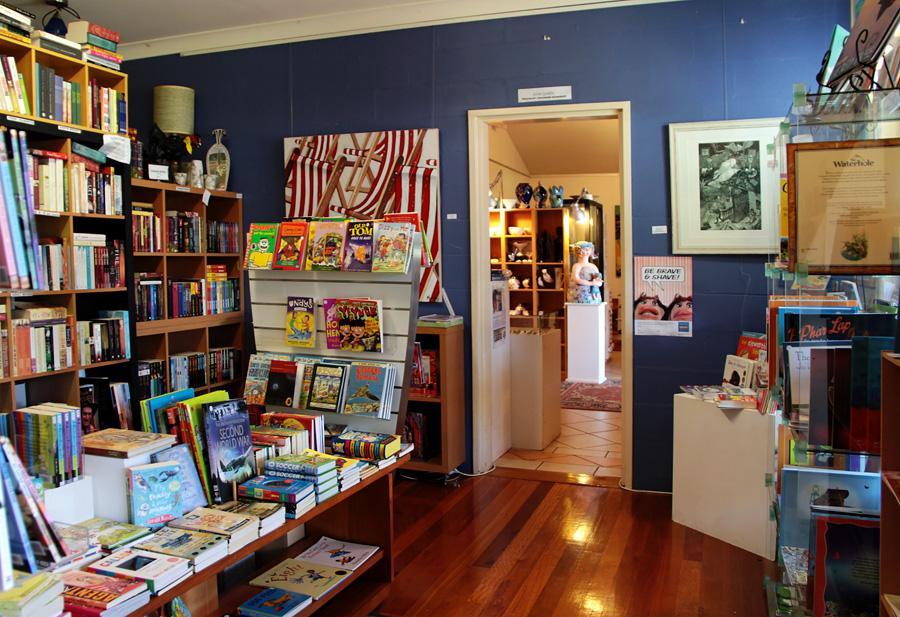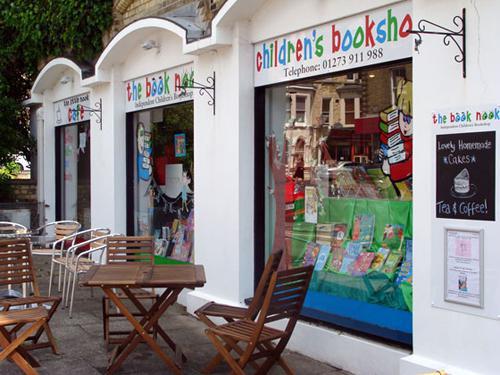The first image is the image on the left, the second image is the image on the right. Assess this claim about the two images: "There is at least one person in the image on the right.". Correct or not? Answer yes or no. No. The first image is the image on the left, the second image is the image on the right. Evaluate the accuracy of this statement regarding the images: "In one image, the bookshelves themselves are bright yellow.". Is it true? Answer yes or no. No. 